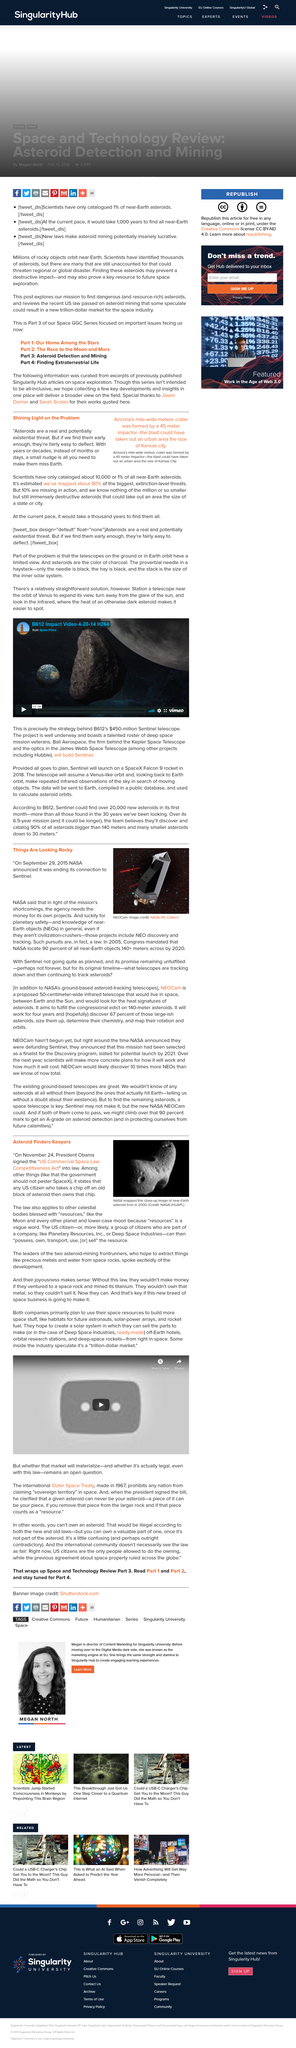Point out several critical features in this image. NEOCam, a proposed 50-centimeter-wide infrared telescope, will reside in space, positioned between Earth and the Sun, and will detect the heat signatures of asteroids in order to identify and track potential asteroid impacts. The image of the near-Earth asteroid Eros was taken in 2000. In 2005, Congress mandated that NASA locate 90% of all near-Earth objects that are 140 meters or larger in diameter by the year 2020. On November 24, 2015, President Barack Obama signed the "US Commercial Space Law Competitiveness Act" into law. The asteroid with a diameter of 45 meters could have potentially destroyed Kansas City. 